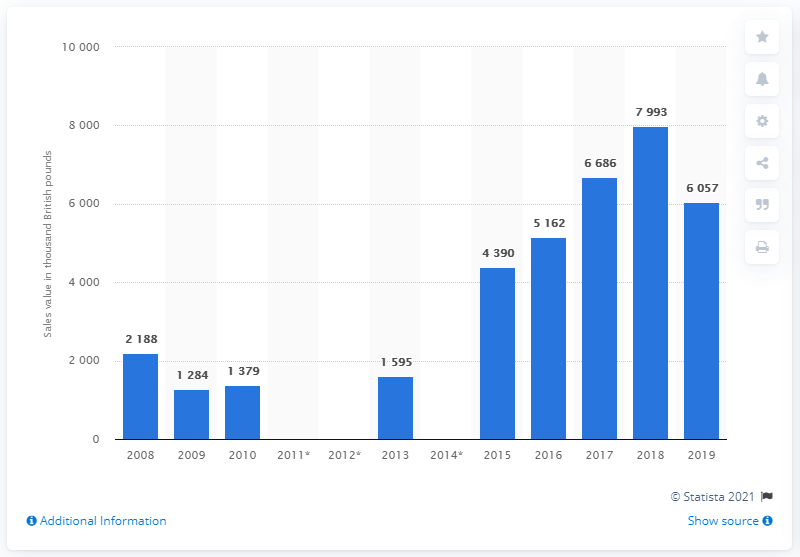Mention a couple of crucial points in this snapshot. Soy sauce was sold in the UK as recently as 2008. 